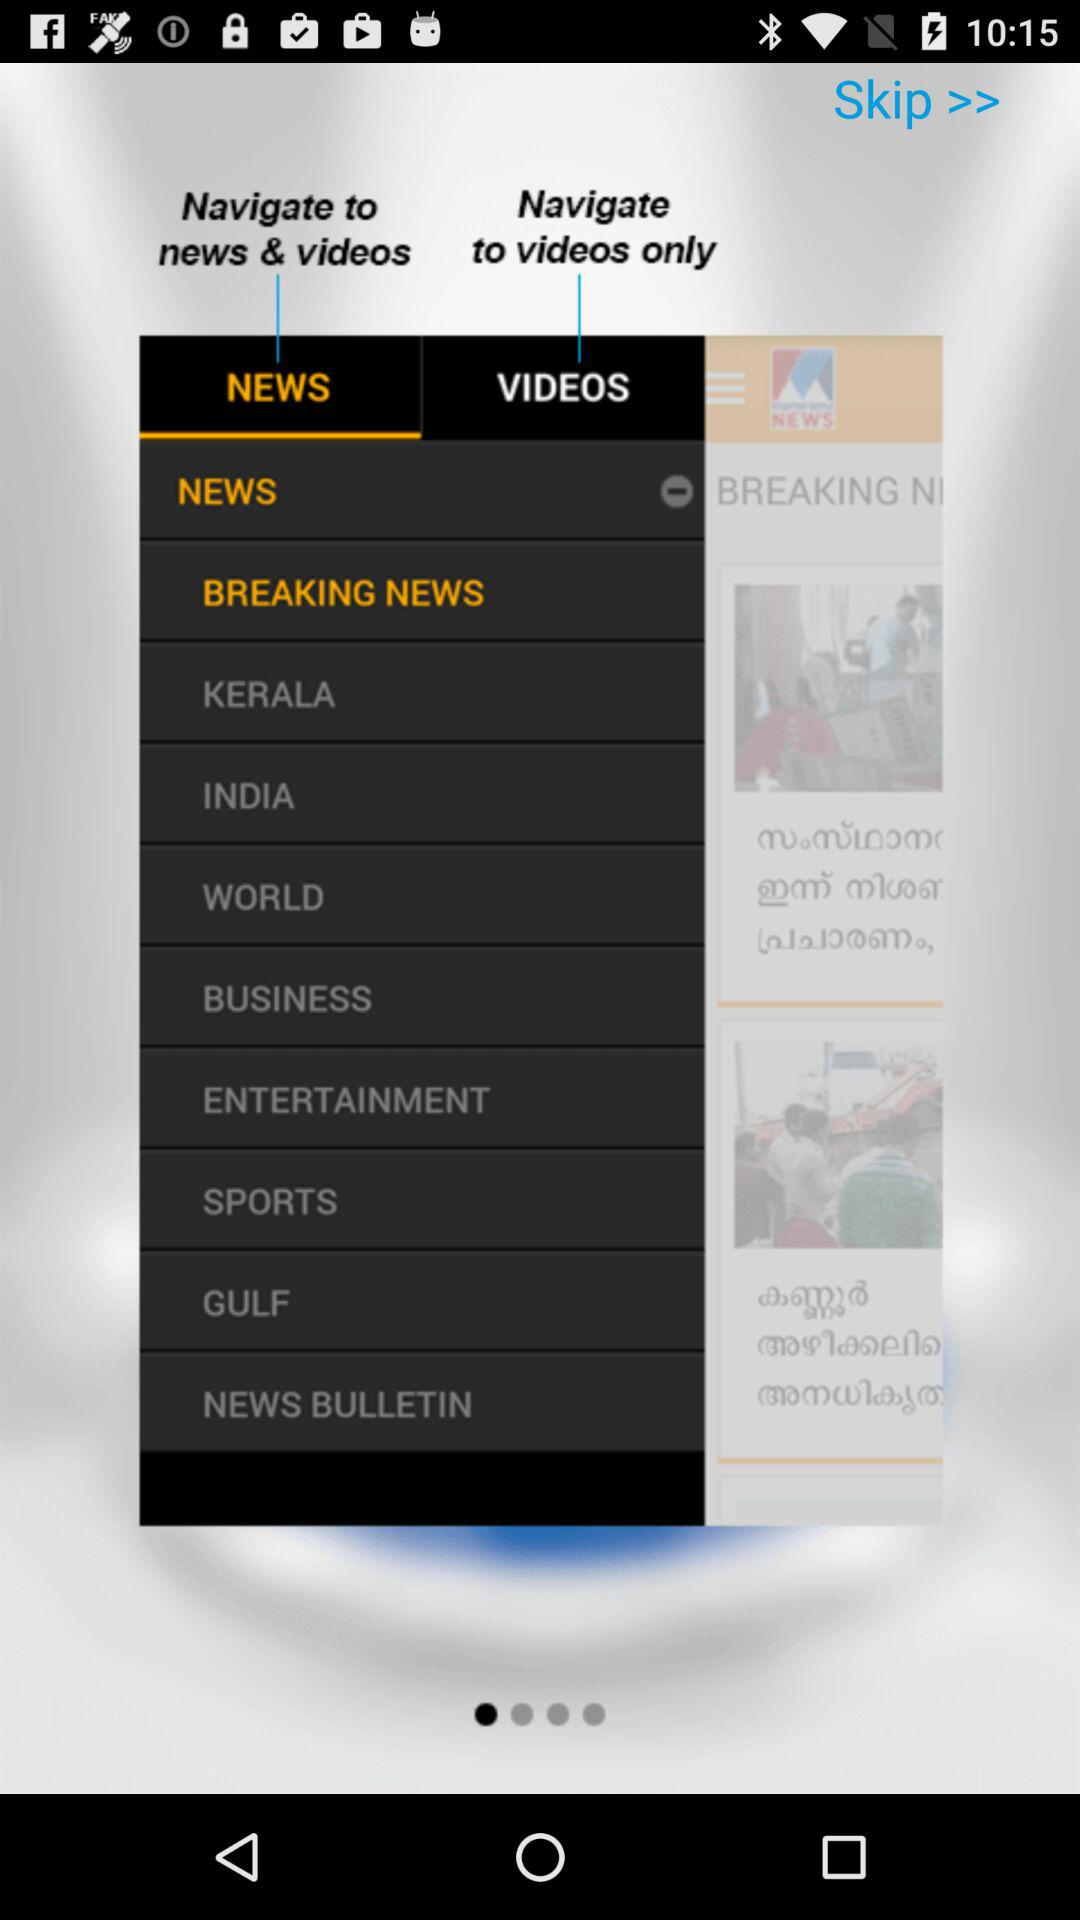Which tab is selected? The selected tab is "NEWS". 